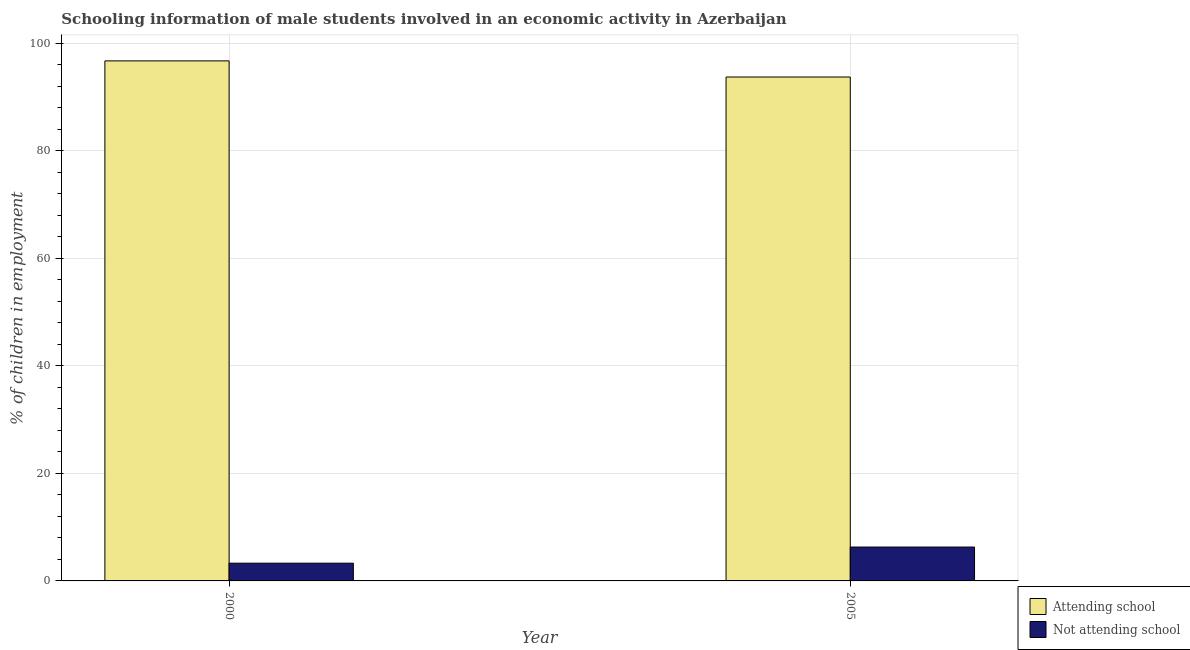How many different coloured bars are there?
Offer a very short reply. 2. How many bars are there on the 1st tick from the left?
Give a very brief answer. 2. In how many cases, is the number of bars for a given year not equal to the number of legend labels?
Provide a succinct answer. 0. What is the percentage of employed males who are attending school in 2000?
Keep it short and to the point. 96.7. Across all years, what is the minimum percentage of employed males who are attending school?
Give a very brief answer. 93.7. In which year was the percentage of employed males who are not attending school maximum?
Keep it short and to the point. 2005. What is the total percentage of employed males who are not attending school in the graph?
Give a very brief answer. 9.6. What is the difference between the percentage of employed males who are not attending school in 2000 and that in 2005?
Offer a very short reply. -3. What is the difference between the percentage of employed males who are not attending school in 2005 and the percentage of employed males who are attending school in 2000?
Provide a succinct answer. 3. What is the average percentage of employed males who are not attending school per year?
Make the answer very short. 4.8. In the year 2000, what is the difference between the percentage of employed males who are not attending school and percentage of employed males who are attending school?
Provide a short and direct response. 0. What is the ratio of the percentage of employed males who are not attending school in 2000 to that in 2005?
Ensure brevity in your answer.  0.52. Is the percentage of employed males who are not attending school in 2000 less than that in 2005?
Ensure brevity in your answer.  Yes. In how many years, is the percentage of employed males who are attending school greater than the average percentage of employed males who are attending school taken over all years?
Offer a very short reply. 1. What does the 1st bar from the left in 2000 represents?
Keep it short and to the point. Attending school. What does the 1st bar from the right in 2005 represents?
Your answer should be compact. Not attending school. How many bars are there?
Offer a terse response. 4. Are all the bars in the graph horizontal?
Keep it short and to the point. No. How many years are there in the graph?
Offer a very short reply. 2. What is the difference between two consecutive major ticks on the Y-axis?
Offer a very short reply. 20. Does the graph contain grids?
Offer a very short reply. Yes. Where does the legend appear in the graph?
Offer a terse response. Bottom right. What is the title of the graph?
Your response must be concise. Schooling information of male students involved in an economic activity in Azerbaijan. Does "Methane" appear as one of the legend labels in the graph?
Give a very brief answer. No. What is the label or title of the X-axis?
Offer a very short reply. Year. What is the label or title of the Y-axis?
Offer a very short reply. % of children in employment. What is the % of children in employment of Attending school in 2000?
Your answer should be compact. 96.7. What is the % of children in employment in Not attending school in 2000?
Offer a very short reply. 3.3. What is the % of children in employment of Attending school in 2005?
Make the answer very short. 93.7. Across all years, what is the maximum % of children in employment in Attending school?
Your answer should be compact. 96.7. Across all years, what is the maximum % of children in employment of Not attending school?
Your answer should be very brief. 6.3. Across all years, what is the minimum % of children in employment in Attending school?
Provide a succinct answer. 93.7. Across all years, what is the minimum % of children in employment in Not attending school?
Provide a short and direct response. 3.3. What is the total % of children in employment in Attending school in the graph?
Ensure brevity in your answer.  190.4. What is the total % of children in employment of Not attending school in the graph?
Your answer should be compact. 9.6. What is the difference between the % of children in employment of Attending school in 2000 and that in 2005?
Make the answer very short. 3. What is the difference between the % of children in employment in Not attending school in 2000 and that in 2005?
Your response must be concise. -3. What is the difference between the % of children in employment in Attending school in 2000 and the % of children in employment in Not attending school in 2005?
Ensure brevity in your answer.  90.4. What is the average % of children in employment in Attending school per year?
Offer a very short reply. 95.2. What is the average % of children in employment of Not attending school per year?
Your answer should be very brief. 4.8. In the year 2000, what is the difference between the % of children in employment in Attending school and % of children in employment in Not attending school?
Offer a very short reply. 93.4. In the year 2005, what is the difference between the % of children in employment of Attending school and % of children in employment of Not attending school?
Keep it short and to the point. 87.4. What is the ratio of the % of children in employment in Attending school in 2000 to that in 2005?
Keep it short and to the point. 1.03. What is the ratio of the % of children in employment in Not attending school in 2000 to that in 2005?
Make the answer very short. 0.52. What is the difference between the highest and the second highest % of children in employment of Attending school?
Your response must be concise. 3. What is the difference between the highest and the second highest % of children in employment in Not attending school?
Your answer should be compact. 3. What is the difference between the highest and the lowest % of children in employment in Attending school?
Provide a succinct answer. 3. What is the difference between the highest and the lowest % of children in employment in Not attending school?
Your response must be concise. 3. 